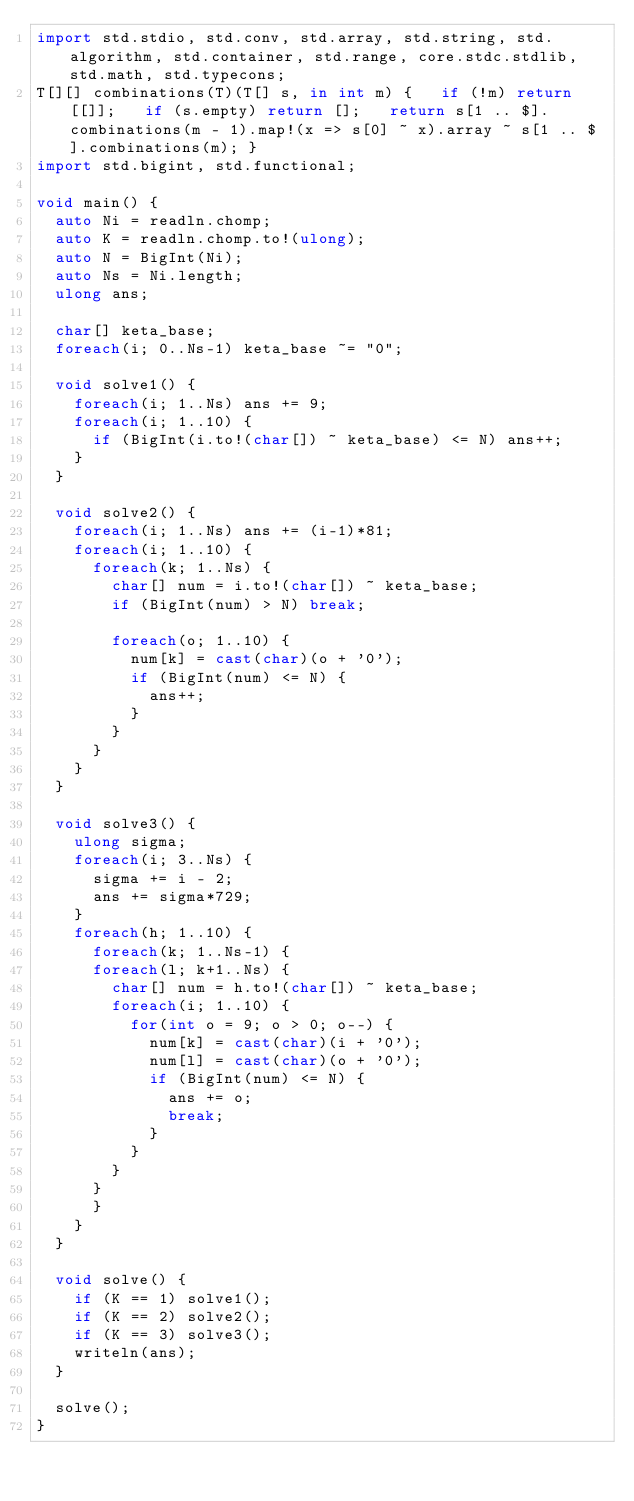Convert code to text. <code><loc_0><loc_0><loc_500><loc_500><_D_>import std.stdio, std.conv, std.array, std.string, std.algorithm, std.container, std.range, core.stdc.stdlib, std.math, std.typecons;
T[][] combinations(T)(T[] s, in int m) {   if (!m) return [[]];   if (s.empty) return [];   return s[1 .. $].combinations(m - 1).map!(x => s[0] ~ x).array ~ s[1 .. $].combinations(m); }
import std.bigint, std.functional;

void main() {
  auto Ni = readln.chomp;
  auto K = readln.chomp.to!(ulong);
  auto N = BigInt(Ni);
  auto Ns = Ni.length;
  ulong ans;

  char[] keta_base;
  foreach(i; 0..Ns-1) keta_base ~= "0";

  void solve1() {
    foreach(i; 1..Ns) ans += 9;
    foreach(i; 1..10) {
      if (BigInt(i.to!(char[]) ~ keta_base) <= N) ans++;
    }
  }

  void solve2() {
    foreach(i; 1..Ns) ans += (i-1)*81;
    foreach(i; 1..10) {
      foreach(k; 1..Ns) {
        char[] num = i.to!(char[]) ~ keta_base;
        if (BigInt(num) > N) break;

        foreach(o; 1..10) {
          num[k] = cast(char)(o + '0');
          if (BigInt(num) <= N) {
            ans++;
          }
        }
      }
    }
  }

  void solve3() {
    ulong sigma;
    foreach(i; 3..Ns) {
      sigma += i - 2;
      ans += sigma*729;
    }
    foreach(h; 1..10) {
      foreach(k; 1..Ns-1) {
      foreach(l; k+1..Ns) {
        char[] num = h.to!(char[]) ~ keta_base;
        foreach(i; 1..10) {
          for(int o = 9; o > 0; o--) {
            num[k] = cast(char)(i + '0');
            num[l] = cast(char)(o + '0');
            if (BigInt(num) <= N) {
              ans += o;
              break;
            }
          }
        }
      }
      }
    }
  }

  void solve() {
    if (K == 1) solve1();
    if (K == 2) solve2();
    if (K == 3) solve3();
    writeln(ans);
  }

  solve();
}
</code> 